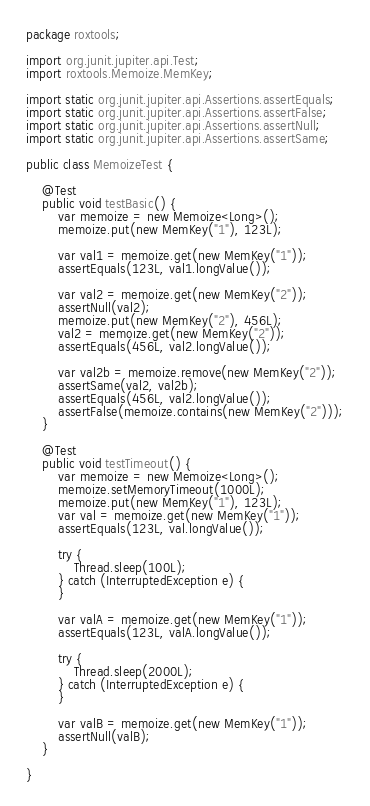<code> <loc_0><loc_0><loc_500><loc_500><_Java_>package roxtools;

import org.junit.jupiter.api.Test;
import roxtools.Memoize.MemKey;

import static org.junit.jupiter.api.Assertions.assertEquals;
import static org.junit.jupiter.api.Assertions.assertFalse;
import static org.junit.jupiter.api.Assertions.assertNull;
import static org.junit.jupiter.api.Assertions.assertSame;

public class MemoizeTest {

    @Test
    public void testBasic() {
        var memoize = new Memoize<Long>();
        memoize.put(new MemKey("1"), 123L);

        var val1 = memoize.get(new MemKey("1"));
        assertEquals(123L, val1.longValue());

        var val2 = memoize.get(new MemKey("2"));
        assertNull(val2);
        memoize.put(new MemKey("2"), 456L);
        val2 = memoize.get(new MemKey("2"));
        assertEquals(456L, val2.longValue());

        var val2b = memoize.remove(new MemKey("2"));
        assertSame(val2, val2b);
        assertEquals(456L, val2.longValue());
        assertFalse(memoize.contains(new MemKey("2")));
    }

    @Test
    public void testTimeout() {
        var memoize = new Memoize<Long>();
        memoize.setMemoryTimeout(1000L);
        memoize.put(new MemKey("1"), 123L);
        var val = memoize.get(new MemKey("1"));
        assertEquals(123L, val.longValue());

        try {
            Thread.sleep(100L);
        } catch (InterruptedException e) {
        }

        var valA = memoize.get(new MemKey("1"));
        assertEquals(123L, valA.longValue());

        try {
            Thread.sleep(2000L);
        } catch (InterruptedException e) {
        }

        var valB = memoize.get(new MemKey("1"));
        assertNull(valB);
    }

}
</code> 